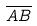<formula> <loc_0><loc_0><loc_500><loc_500>\overline { A B }</formula> 